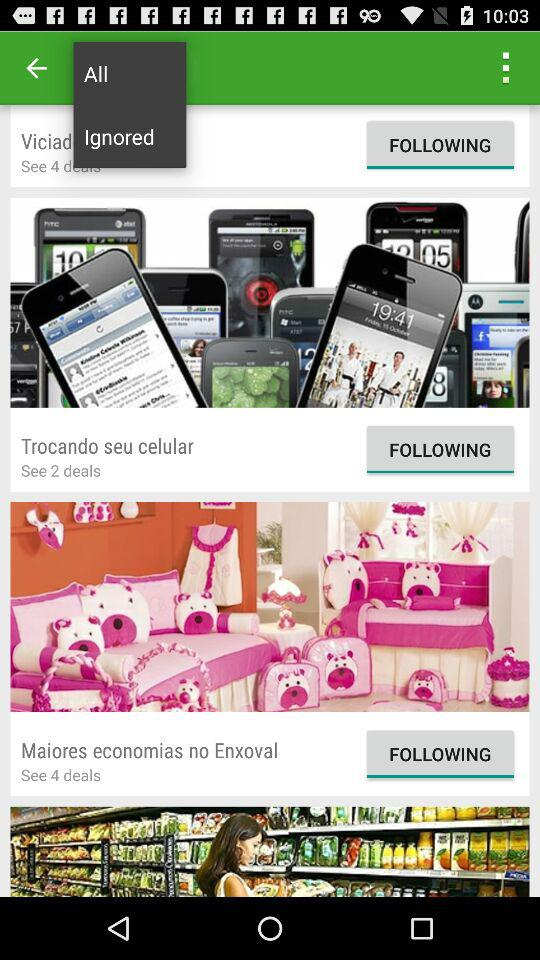How many deals are there for "Trocando seu celular"? There are two deals for "Trocando seu celular". 